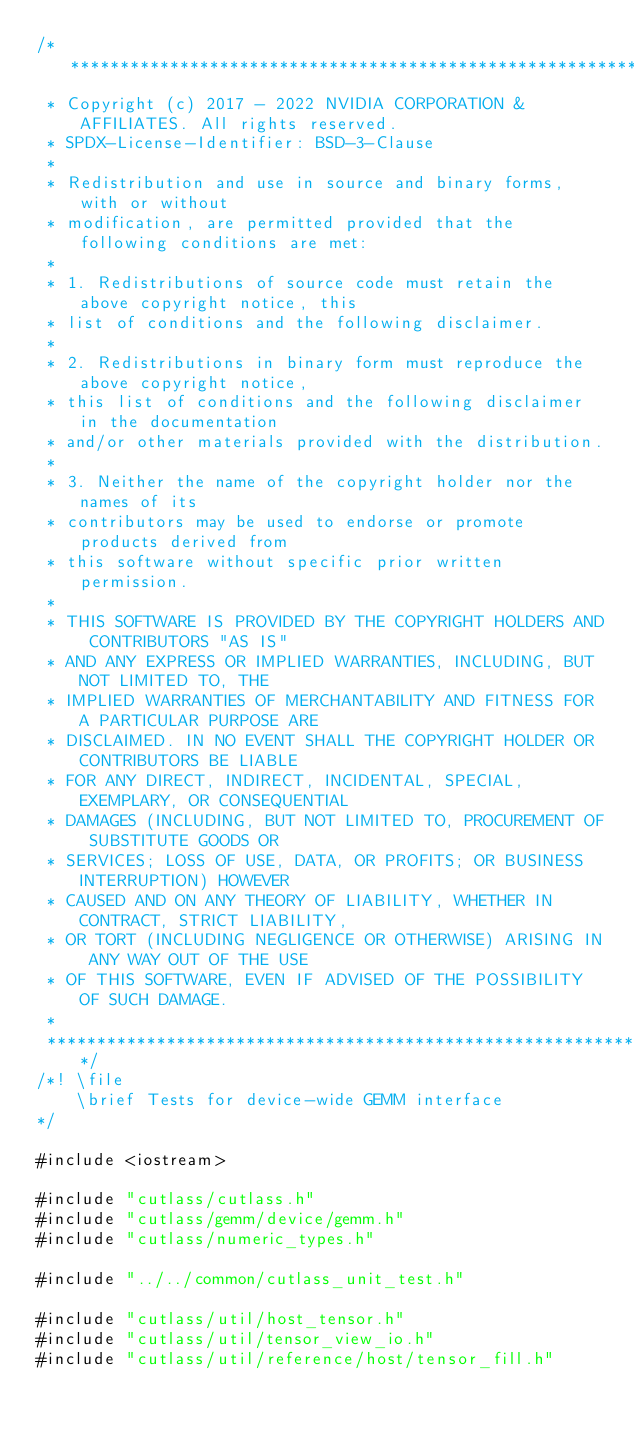<code> <loc_0><loc_0><loc_500><loc_500><_Cuda_>/***************************************************************************************************
 * Copyright (c) 2017 - 2022 NVIDIA CORPORATION & AFFILIATES. All rights reserved.
 * SPDX-License-Identifier: BSD-3-Clause
 *
 * Redistribution and use in source and binary forms, with or without
 * modification, are permitted provided that the following conditions are met:
 *
 * 1. Redistributions of source code must retain the above copyright notice, this
 * list of conditions and the following disclaimer.
 *
 * 2. Redistributions in binary form must reproduce the above copyright notice,
 * this list of conditions and the following disclaimer in the documentation
 * and/or other materials provided with the distribution.
 *
 * 3. Neither the name of the copyright holder nor the names of its
 * contributors may be used to endorse or promote products derived from
 * this software without specific prior written permission.
 *
 * THIS SOFTWARE IS PROVIDED BY THE COPYRIGHT HOLDERS AND CONTRIBUTORS "AS IS"
 * AND ANY EXPRESS OR IMPLIED WARRANTIES, INCLUDING, BUT NOT LIMITED TO, THE
 * IMPLIED WARRANTIES OF MERCHANTABILITY AND FITNESS FOR A PARTICULAR PURPOSE ARE
 * DISCLAIMED. IN NO EVENT SHALL THE COPYRIGHT HOLDER OR CONTRIBUTORS BE LIABLE
 * FOR ANY DIRECT, INDIRECT, INCIDENTAL, SPECIAL, EXEMPLARY, OR CONSEQUENTIAL
 * DAMAGES (INCLUDING, BUT NOT LIMITED TO, PROCUREMENT OF SUBSTITUTE GOODS OR
 * SERVICES; LOSS OF USE, DATA, OR PROFITS; OR BUSINESS INTERRUPTION) HOWEVER
 * CAUSED AND ON ANY THEORY OF LIABILITY, WHETHER IN CONTRACT, STRICT LIABILITY,
 * OR TORT (INCLUDING NEGLIGENCE OR OTHERWISE) ARISING IN ANY WAY OUT OF THE USE
 * OF THIS SOFTWARE, EVEN IF ADVISED OF THE POSSIBILITY OF SUCH DAMAGE.
 *
 **************************************************************************************************/
/*! \file
    \brief Tests for device-wide GEMM interface
*/

#include <iostream>

#include "cutlass/cutlass.h"
#include "cutlass/gemm/device/gemm.h"
#include "cutlass/numeric_types.h"

#include "../../common/cutlass_unit_test.h"

#include "cutlass/util/host_tensor.h"
#include "cutlass/util/tensor_view_io.h"
#include "cutlass/util/reference/host/tensor_fill.h"</code> 